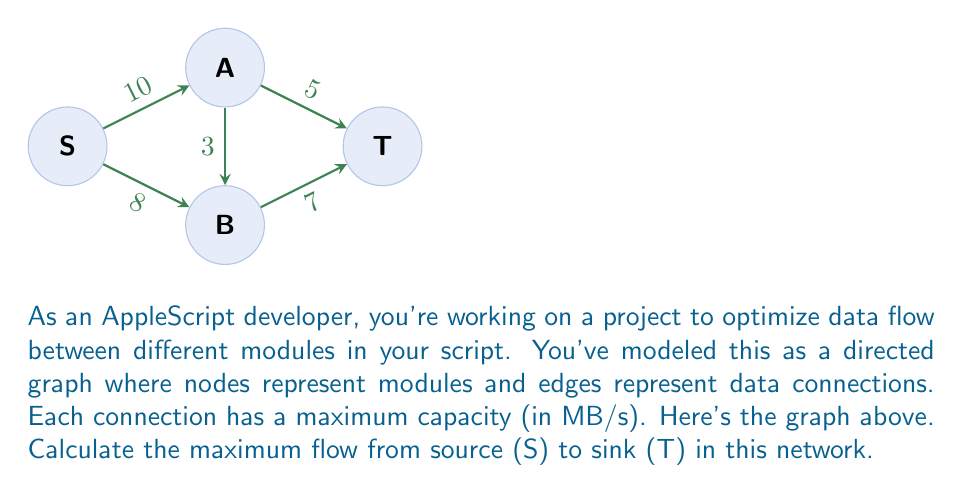What is the answer to this math problem? To solve this problem, we'll use the Ford-Fulkerson algorithm:

1) Initialize flow to 0 for all edges.

2) While there exists an augmenting path from S to T:
   a) Find the minimum capacity along this path
   b) Add this capacity to the total flow
   c) Update residual graph

3) Augmenting paths:

   Path 1: S -> A -> T
   Min capacity: min(10, 5) = 5
   Flow becomes 5

   Residual graph:
   S -> A: 5/10
   A -> T: 5/5 (saturated)

   Path 2: S -> B -> T
   Min capacity: min(8, 7) = 7
   Flow becomes 5 + 7 = 12

   Residual graph:
   S -> A: 5/10
   A -> T: 5/5 (saturated)
   S -> B: 7/8
   B -> T: 7/7 (saturated)

   Path 3: S -> A -> B -> T
   Min capacity: min(5, 3, 0) = 0

No more augmenting paths exist.

4) The maximum flow is the sum of all flows out of S, which is 12 MB/s.
Answer: 12 MB/s 